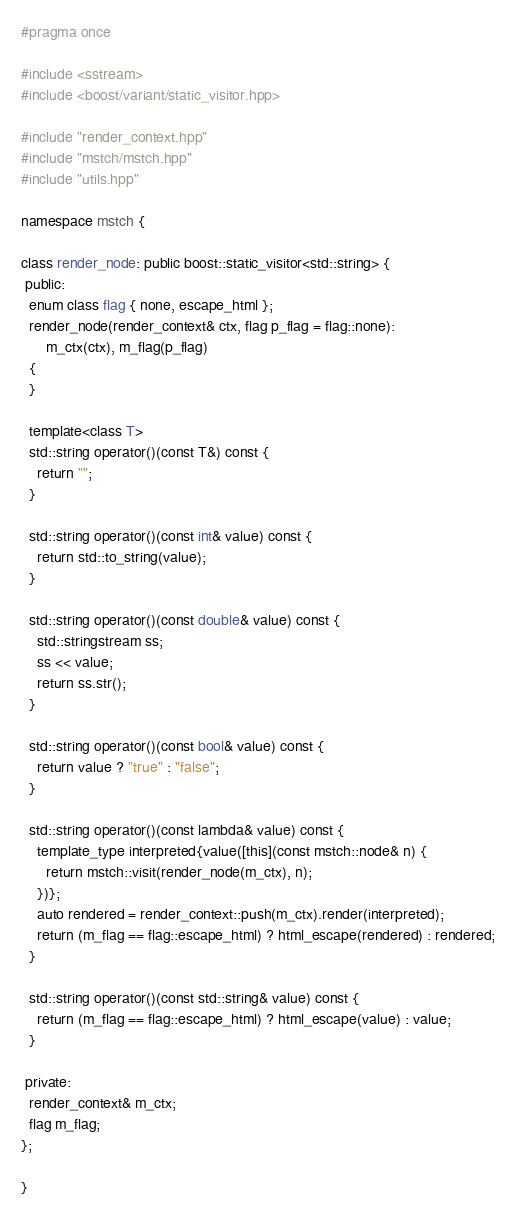<code> <loc_0><loc_0><loc_500><loc_500><_C++_>#pragma once

#include <sstream>
#include <boost/variant/static_visitor.hpp>

#include "render_context.hpp"
#include "mstch/mstch.hpp"
#include "utils.hpp"

namespace mstch {

class render_node: public boost::static_visitor<std::string> {
 public:
  enum class flag { none, escape_html };
  render_node(render_context& ctx, flag p_flag = flag::none):
      m_ctx(ctx), m_flag(p_flag)
  {
  }

  template<class T>
  std::string operator()(const T&) const {
    return "";
  }

  std::string operator()(const int& value) const {
    return std::to_string(value);
  }

  std::string operator()(const double& value) const {
    std::stringstream ss;
    ss << value;
    return ss.str();
  }

  std::string operator()(const bool& value) const {
    return value ? "true" : "false";
  }

  std::string operator()(const lambda& value) const {
    template_type interpreted{value([this](const mstch::node& n) {
      return mstch::visit(render_node(m_ctx), n);
    })};
    auto rendered = render_context::push(m_ctx).render(interpreted);
    return (m_flag == flag::escape_html) ? html_escape(rendered) : rendered;
  }

  std::string operator()(const std::string& value) const {
    return (m_flag == flag::escape_html) ? html_escape(value) : value;
  }

 private:
  render_context& m_ctx;
  flag m_flag;
};

}
</code> 